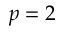<formula> <loc_0><loc_0><loc_500><loc_500>p = 2</formula> 